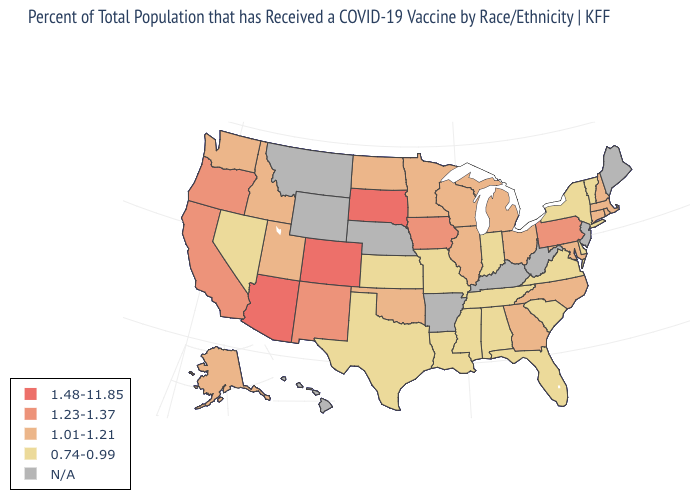What is the highest value in states that border New York?
Quick response, please. 1.23-1.37. Name the states that have a value in the range 1.01-1.21?
Answer briefly. Alaska, Connecticut, Georgia, Idaho, Illinois, Maryland, Massachusetts, Michigan, Minnesota, New Hampshire, North Carolina, North Dakota, Ohio, Oklahoma, Rhode Island, Utah, Washington, Wisconsin. Among the states that border Virginia , does Maryland have the lowest value?
Answer briefly. No. Does South Dakota have the highest value in the MidWest?
Quick response, please. Yes. Among the states that border Iowa , which have the highest value?
Write a very short answer. South Dakota. What is the value of Tennessee?
Quick response, please. 0.74-0.99. What is the value of Kentucky?
Short answer required. N/A. What is the value of Oklahoma?
Keep it brief. 1.01-1.21. Among the states that border North Carolina , which have the lowest value?
Give a very brief answer. South Carolina, Tennessee, Virginia. Name the states that have a value in the range 0.74-0.99?
Answer briefly. Alabama, Delaware, Florida, Indiana, Kansas, Louisiana, Mississippi, Missouri, Nevada, New York, South Carolina, Tennessee, Texas, Vermont, Virginia. What is the value of Arkansas?
Quick response, please. N/A. Name the states that have a value in the range 1.23-1.37?
Keep it brief. California, Iowa, New Mexico, Oregon, Pennsylvania. What is the highest value in the USA?
Give a very brief answer. 1.48-11.85. 